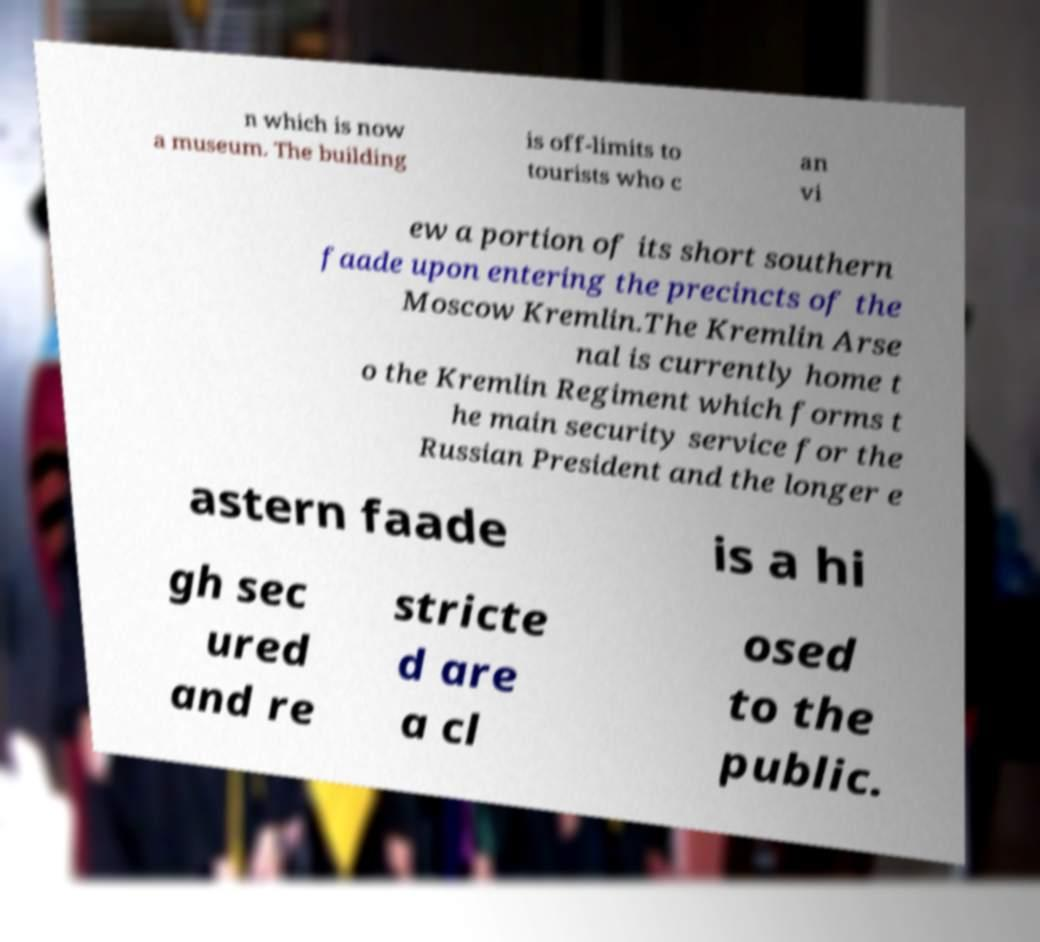Can you read and provide the text displayed in the image?This photo seems to have some interesting text. Can you extract and type it out for me? n which is now a museum. The building is off-limits to tourists who c an vi ew a portion of its short southern faade upon entering the precincts of the Moscow Kremlin.The Kremlin Arse nal is currently home t o the Kremlin Regiment which forms t he main security service for the Russian President and the longer e astern faade is a hi gh sec ured and re stricte d are a cl osed to the public. 